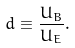Convert formula to latex. <formula><loc_0><loc_0><loc_500><loc_500>d \equiv \frac { U _ { B } } { U _ { E } } .</formula> 